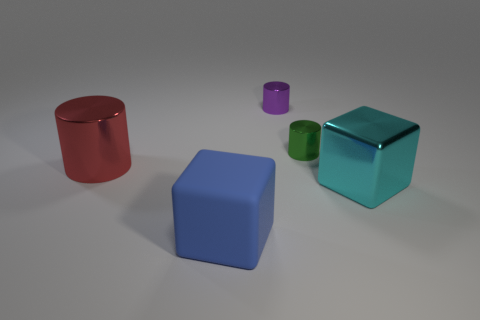Subtract all tiny green metal cylinders. How many cylinders are left? 2 Subtract all blue blocks. How many blocks are left? 1 Subtract all cylinders. How many objects are left? 2 Add 3 big cylinders. How many objects exist? 8 Subtract all yellow blocks. Subtract all cyan cylinders. How many blocks are left? 2 Subtract all purple balls. How many brown blocks are left? 0 Subtract all large rubber blocks. Subtract all cylinders. How many objects are left? 1 Add 3 purple metallic things. How many purple metallic things are left? 4 Add 5 small green metal cylinders. How many small green metal cylinders exist? 6 Subtract 1 red cylinders. How many objects are left? 4 